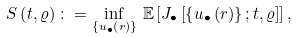Convert formula to latex. <formula><loc_0><loc_0><loc_500><loc_500>S \left ( t , \varrho \right ) \colon = \inf _ { \left \{ u _ { \bullet } \left ( r \right ) \right \} } \, \mathbb { E } \left [ J _ { \bullet } \left [ \left \{ u _ { \bullet } \left ( r \right ) \right \} ; t , \varrho \right ] \right ] ,</formula> 